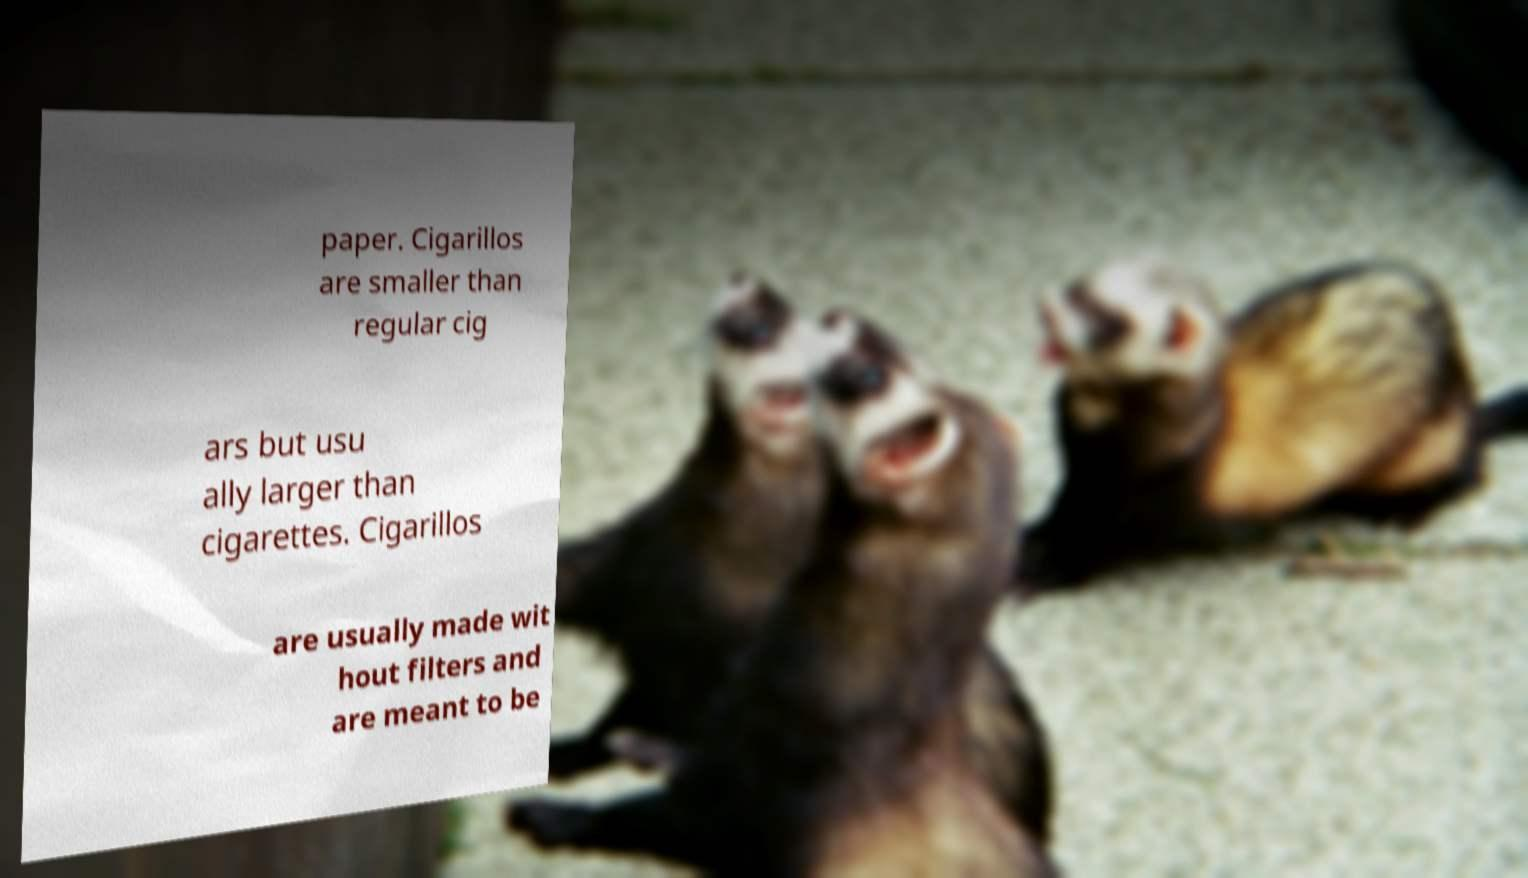What messages or text are displayed in this image? I need them in a readable, typed format. paper. Cigarillos are smaller than regular cig ars but usu ally larger than cigarettes. Cigarillos are usually made wit hout filters and are meant to be 